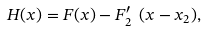<formula> <loc_0><loc_0><loc_500><loc_500>H ( x ) = F ( x ) - F ^ { \prime } _ { 2 } \ ( x - x _ { 2 } ) ,</formula> 